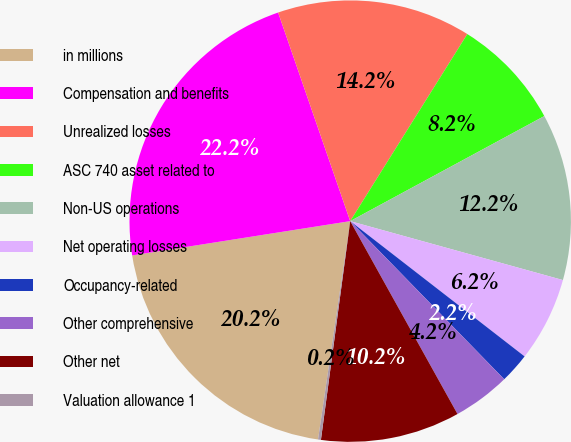Convert chart to OTSL. <chart><loc_0><loc_0><loc_500><loc_500><pie_chart><fcel>in millions<fcel>Compensation and benefits<fcel>Unrealized losses<fcel>ASC 740 asset related to<fcel>Non-US operations<fcel>Net operating losses<fcel>Occupancy-related<fcel>Other comprehensive<fcel>Other net<fcel>Valuation allowance 1<nl><fcel>20.19%<fcel>22.19%<fcel>14.2%<fcel>8.2%<fcel>12.2%<fcel>6.2%<fcel>2.21%<fcel>4.21%<fcel>10.2%<fcel>0.21%<nl></chart> 